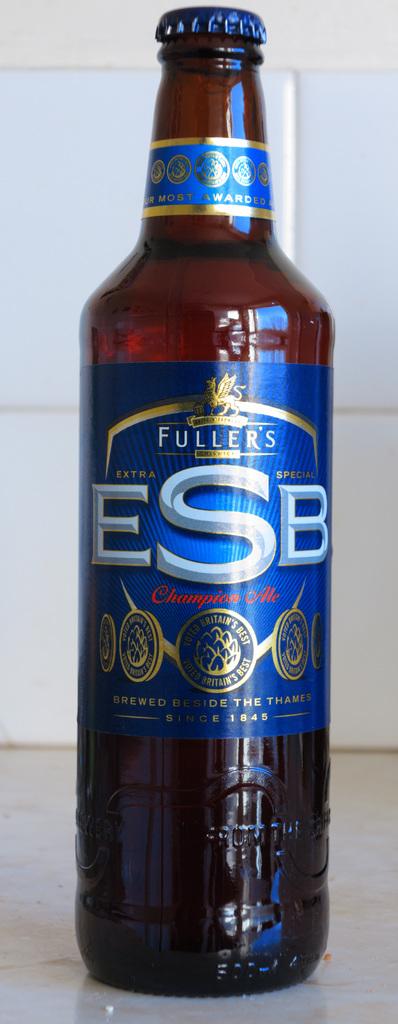What is the brand of beer in the photo?
Make the answer very short. Fuller's. What year is on the bottle?
Give a very brief answer. 1845. 